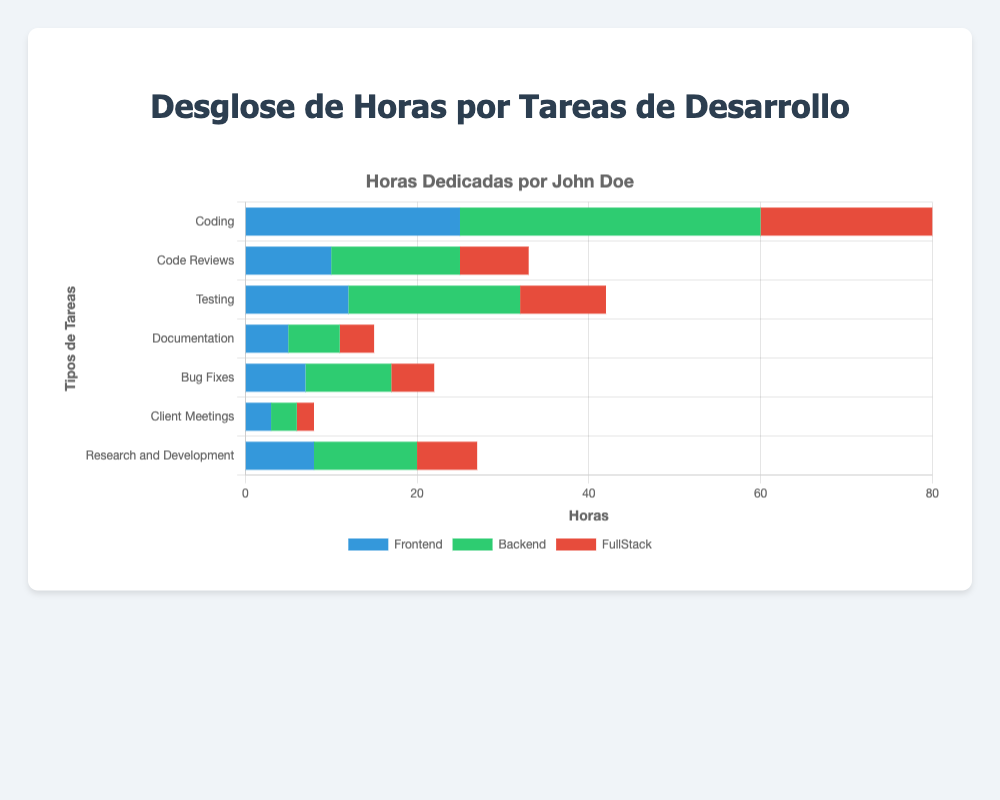Which task type has the highest number of hours for Backend development? The chart shows stacked bars for each task type, with segments representing Backend development colored green. The tallest green segment corresponds to the "Coding" task.
Answer: Coding How many total hours did John Doe spend on FullStack tasks across all task types? To find the total hours spent on FullStack tasks, sum the respective values for each task type: 20 (Coding) + 8 (Code Reviews) + 10 (Testing) + 4 (Documentation) + 5 (Bug Fixes) + 2 (Client Meetings) + 7 (Research and Development) = 56 hours.
Answer: 56 hours Compare the time spent on Frontend versus Backend for Testing tasks. Which one is greater and by how much? The chart shows Testing tasks with a blue segment for Frontend (12 hours) and a green segment for Backend (20 hours). Backend time is greater than Frontend time, and the difference is 20 - 12 = 8 hours.
Answer: Backend by 8 hours What is the average number of hours spent on Documentation tasks, considering all development types? Calculate the average by summing the hours for Frontend (5), Backend (6), and FullStack (4) and then dividing by the number of development types: (5 + 6 + 4)/3 = 15/3 = 5.
Answer: 5 hours Which task type has the smallest total number of hours across all development types, and what is that total? Calculate the total hours for each task type and identify the smallest: (Frontend + Backend + FullStack). Client Meetings: 3 + 3 + 2 = 8, Documentation: 5 + 6 + 4 = 15, etc. Client Meetings is the smallest at 8 hours.
Answer: Client Meetings, 8 hours What is the ratio of time spent on Research and Development for Backend to that for Frontend? The chart shows 12 hours for Backend and 8 hours for Frontend in Research and Development tasks. The ratio is 12:8, which simplifies to 3:2.
Answer: 3:2 For how many task types does John Doe spend more than 30 hours in Backend development? Inspect the chart's green segments for each task type and count any that exceed 30 hours. Only the "Coding" task has more than 30 hours (35 hours).
Answer: 1 task type Calculate the difference in total hours between Coding and Testing tasks across all development types. Sum the hours for each task type: Coding (25 + 35 + 20 = 80), Testing (12 + 20 + 10 = 42). The difference is 80 - 42 = 38 hours.
Answer: 38 hours What is the total number of hours spent on Code Reviews for Frontend and FullStack combined? Sum the hours for Code Reviews in Frontend (10) and FullStack (8): 10 + 8 = 18 hours.
Answer: 18 hours 